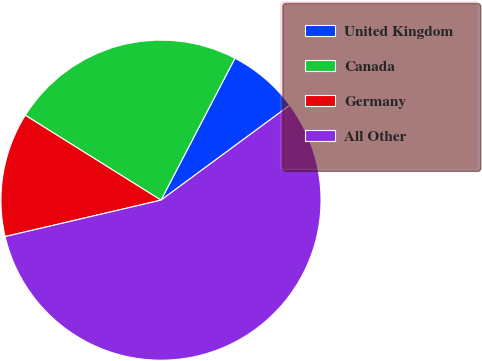Convert chart. <chart><loc_0><loc_0><loc_500><loc_500><pie_chart><fcel>United Kingdom<fcel>Canada<fcel>Germany<fcel>All Other<nl><fcel>7.25%<fcel>23.75%<fcel>12.55%<fcel>56.45%<nl></chart> 